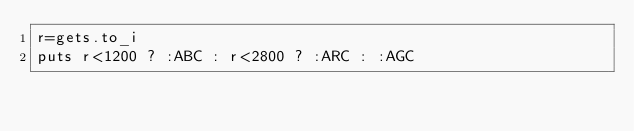<code> <loc_0><loc_0><loc_500><loc_500><_Ruby_>r=gets.to_i
puts r<1200 ? :ABC : r<2800 ? :ARC : :AGC</code> 